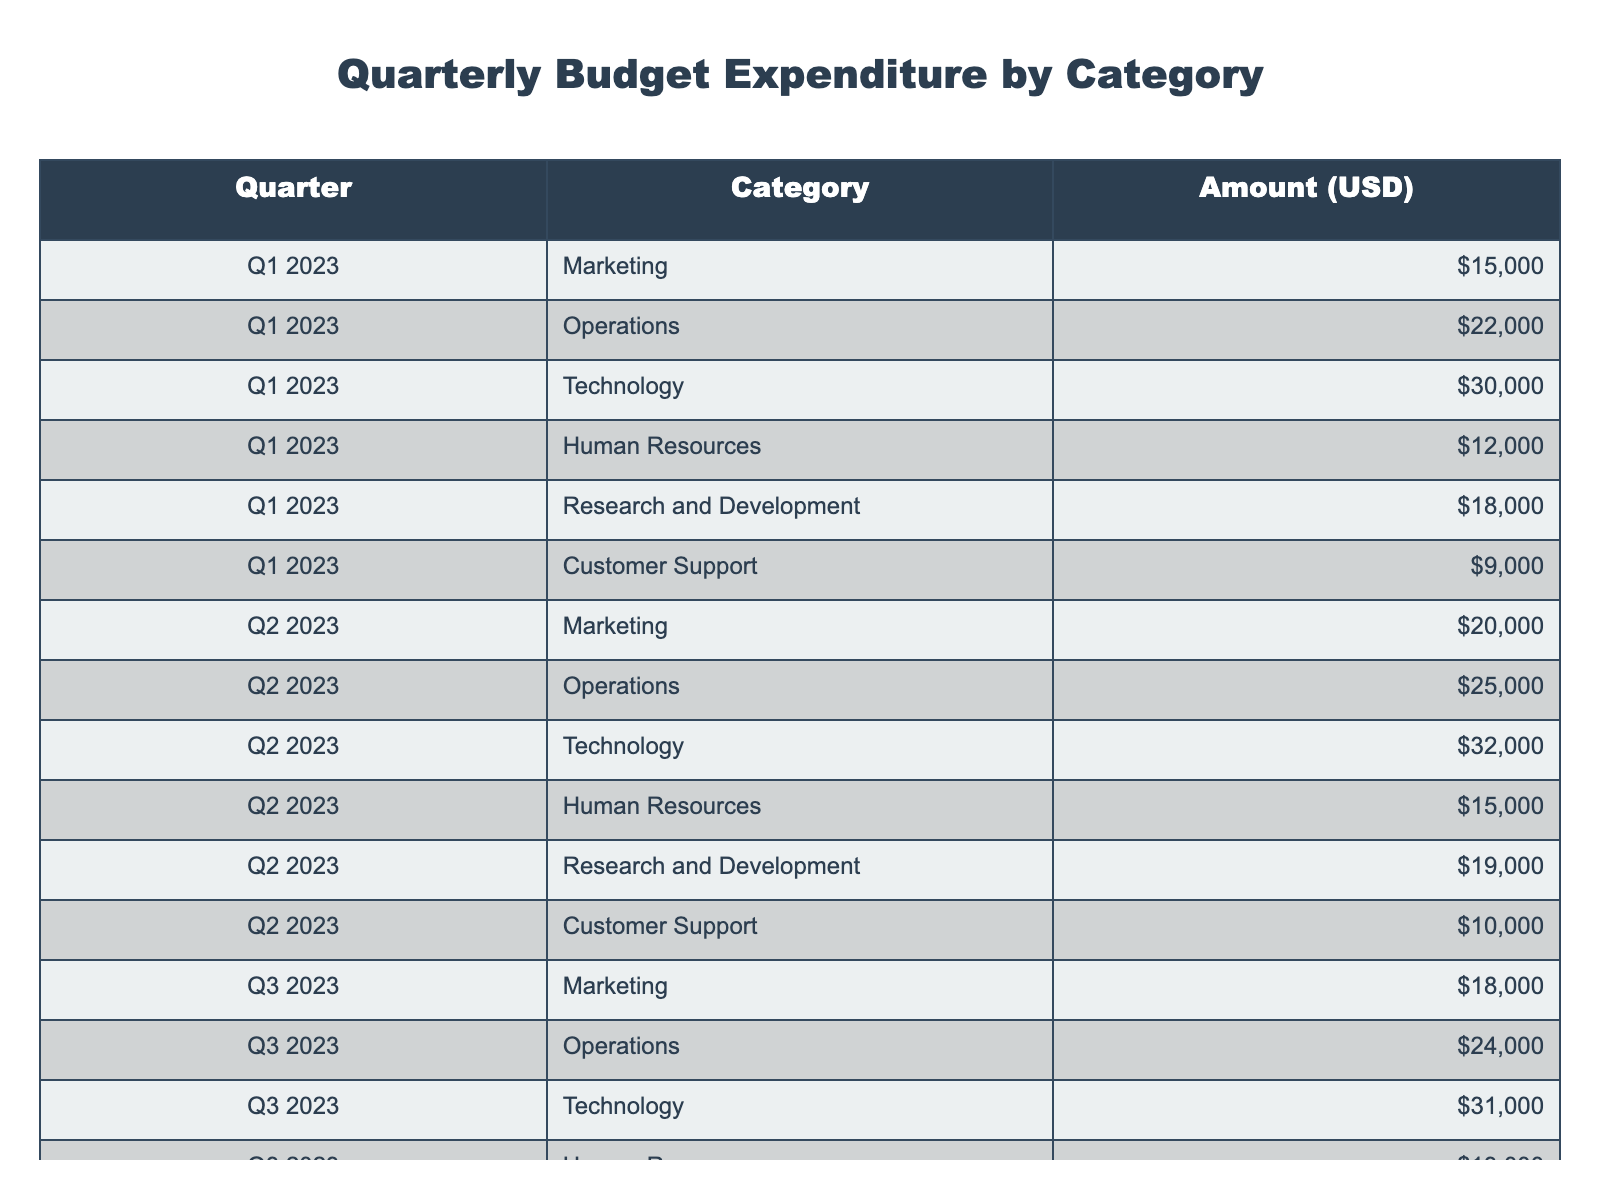What is the total expenditure in Q2 2023? The table shows the amounts for each category in Q2 2023. Adding them up gives us: 20000 (Marketing) + 25000 (Operations) + 32000 (Technology) + 15000 (Human Resources) + 19000 (Research and Development) + 10000 (Customer Support) = 121000.
Answer: 121000 Which category had the highest expenditure in Q4 2023? In Q4 2023, we can look at the amounts: Marketing (25000), Operations (26000), Technology (34000), Human Resources (14000), Research and Development (22000), Customer Support (12000). The highest value is for Technology at 34000.
Answer: Technology What was the average expenditure for Marketing across all four quarters? To find the average, we first sum the Marketing expenditures: 15000 (Q1) + 20000 (Q2) + 18000 (Q3) + 25000 (Q4) = 78000. Then divide by the number of quarters (4), which gives us 78000 / 4 = 19500.
Answer: 19500 Did Customer Support spend more in Q3 than in Q1? In Q3, Customer Support spent 11000 and in Q1, they spent 9000. Since 11000 is greater than 9000, the answer is yes.
Answer: Yes What is the difference in expenditure between Technology in Q2 and Q4? The expenditure for Technology in Q2 is 32000 and in Q4 is 34000. The difference is calculated by subtracting Q2 from Q4: 34000 - 32000 = 2000.
Answer: 2000 Which category showed the smallest expenditure in Q1 2023? In Q1 2023, the expenditures by category are: Marketing (15000), Operations (22000), Technology (30000), Human Resources (12000), Research and Development (18000), Customer Support (9000). The smallest value is for Customer Support at 9000.
Answer: Customer Support What was the total expenditure for Operations across all quarters? Adding the expenditures for Operations across all quarters: 22000 (Q1) + 25000 (Q2) + 24000 (Q3) + 26000 (Q4) = 97000.
Answer: 97000 Is the total expenditure in Q3 higher than the total in Q1? The total for Q3 is calculated as follows: 18000 (Marketing) + 24000 (Operations) + 31000 (Technology) + 13000 (Human Resources) + 20000 (Research and Development) + 11000 (Customer Support) = 108000. For Q1, it is 15000 + 22000 + 30000 + 12000 + 18000 + 9000 = 106000. Since 108000 is greater than 106000, the answer is yes.
Answer: Yes What is the average expenditure across all categories in Q1 2023? For Q1, we sum the amounts: 15000 + 22000 + 30000 + 12000 + 18000 + 9000 = 106000. There are 6 categories, so the average is 106000 / 6 = 17666.67, rounding to 17666.
Answer: 17666 Which quarter had the highest total expenditure overall? We calculate totals for each quarter: Q1 = 106000, Q2 = 121000, Q3 = 108000, Q4 = 120000. The highest total is in Q2 at 121000.
Answer: Q2 What was the total amount spent on Research and Development across all quarters? Adding the amounts for Research and Development gives: 18000 (Q1) + 19000 (Q2) + 20000 (Q3) + 22000 (Q4) = 79000.
Answer: 79000 